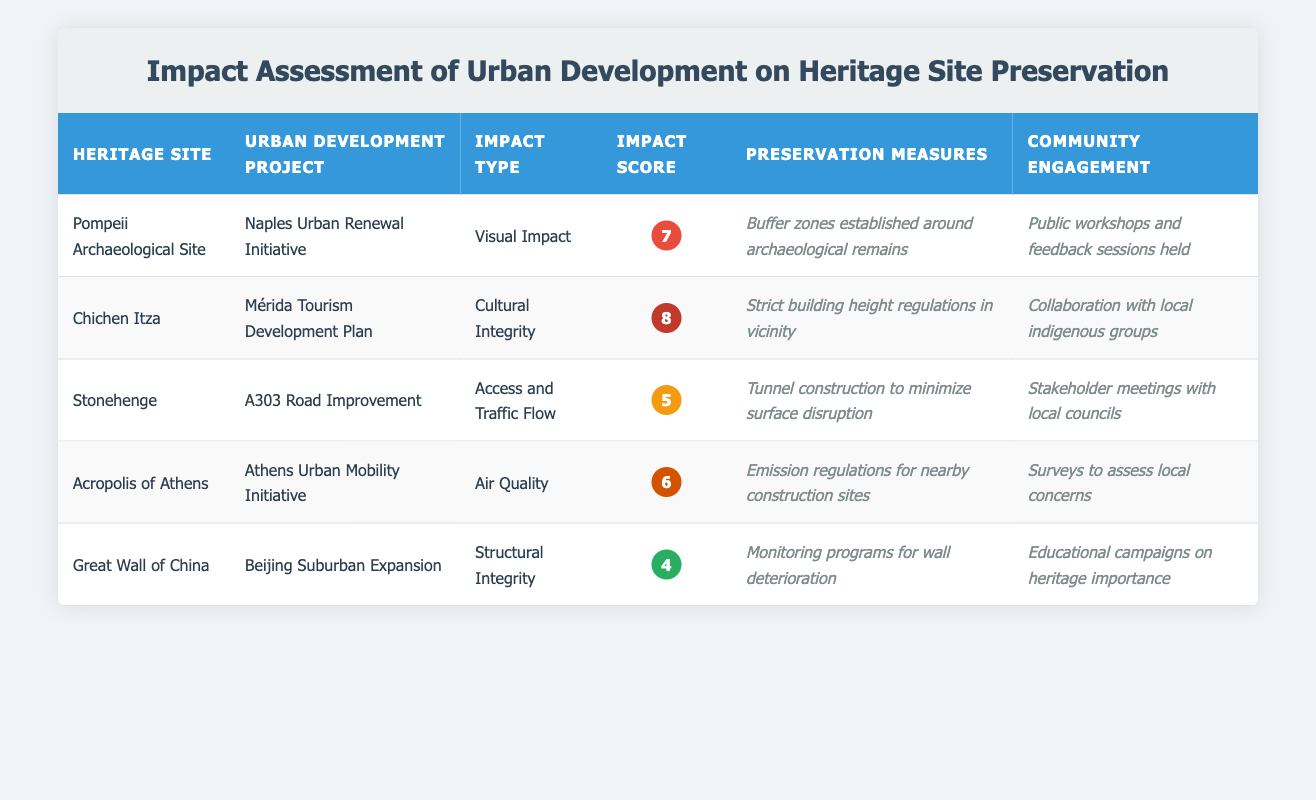What is the impact score for the Great Wall of China? The impact score for the Great Wall of China is listed in the table under the "Impact Score" column for that heritage site. The value is 4.
Answer: 4 Which urban development project has the highest impact score? To determine the highest impact score, we compare all the scores listed in the table: 7 (Pompeii), 8 (Chichen Itza), 5 (Stonehenge), 6 (Acropolis), and 4 (Great Wall). The maximum is 8, which belongs to the Chichen Itza project.
Answer: Chichen Itza Are preservation measures reported for all heritage sites? In the table, every heritage site has corresponding preservation measures documented. Each row under "Preservation Measures" contains information. Therefore, the answer is yes.
Answer: Yes What is the difference between the impact score of Stonehenge and that of Chichen Itza? The impact score for Stonehenge is 5, and for Chichen Itza, it is 8. To find the difference, we subtract: 8 - 5 = 3.
Answer: 3 Is the community engagement for the Acropolis of Athens focused on collaboration with local indigenous groups? The community engagement listed for the Acropolis of Athens mentions surveys to assess local concerns, not collaboration with local indigenous groups, which connects to Chichen Itza. Thus, the answer is no.
Answer: No What are the preservation measures for the Pompeii Archaeological Site? The table specifies that the preservation measures for Pompeii are "Buffer zones established around archaeological remains," as detailed in the respective cell of the preservation measures column.
Answer: Buffer zones established around archaeological remains What is the average impact score of all the projects listed? The impact scores for all sites are 7, 8, 5, 6, and 4. To calculate the average, we sum these values: 7 + 8 + 5 + 6 + 4 = 30, and then divide by the number of sites (5): 30 / 5 = 6.
Answer: 6 Which heritage site has the lowest impact score and what type of impact does it associate with? The lowest impact score in the table is 4, associated with the Great Wall of China, and it corresponds to "Structural Integrity." This information can be found by reviewing all impact scores in the table.
Answer: Great Wall of China, Structural Integrity Did any urban development projects involve community engagement through public workshops? According to the table, public workshops and feedback sessions were held for the Pompeii Archaeological Site. This indicates at least one project did indeed include this form of engagement.
Answer: Yes 